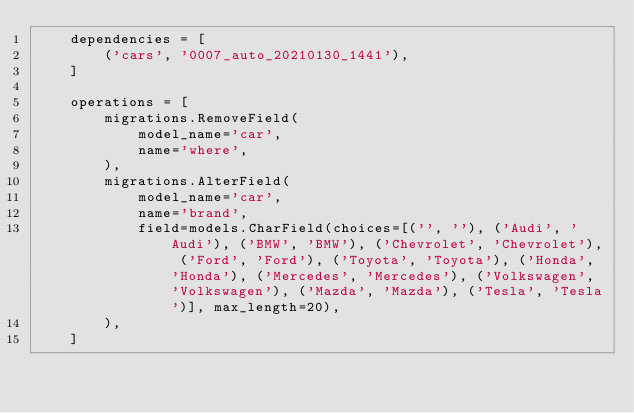<code> <loc_0><loc_0><loc_500><loc_500><_Python_>    dependencies = [
        ('cars', '0007_auto_20210130_1441'),
    ]

    operations = [
        migrations.RemoveField(
            model_name='car',
            name='where',
        ),
        migrations.AlterField(
            model_name='car',
            name='brand',
            field=models.CharField(choices=[('', ''), ('Audi', 'Audi'), ('BMW', 'BMW'), ('Chevrolet', 'Chevrolet'), ('Ford', 'Ford'), ('Toyota', 'Toyota'), ('Honda', 'Honda'), ('Mercedes', 'Mercedes'), ('Volkswagen', 'Volkswagen'), ('Mazda', 'Mazda'), ('Tesla', 'Tesla')], max_length=20),
        ),
    ]
</code> 